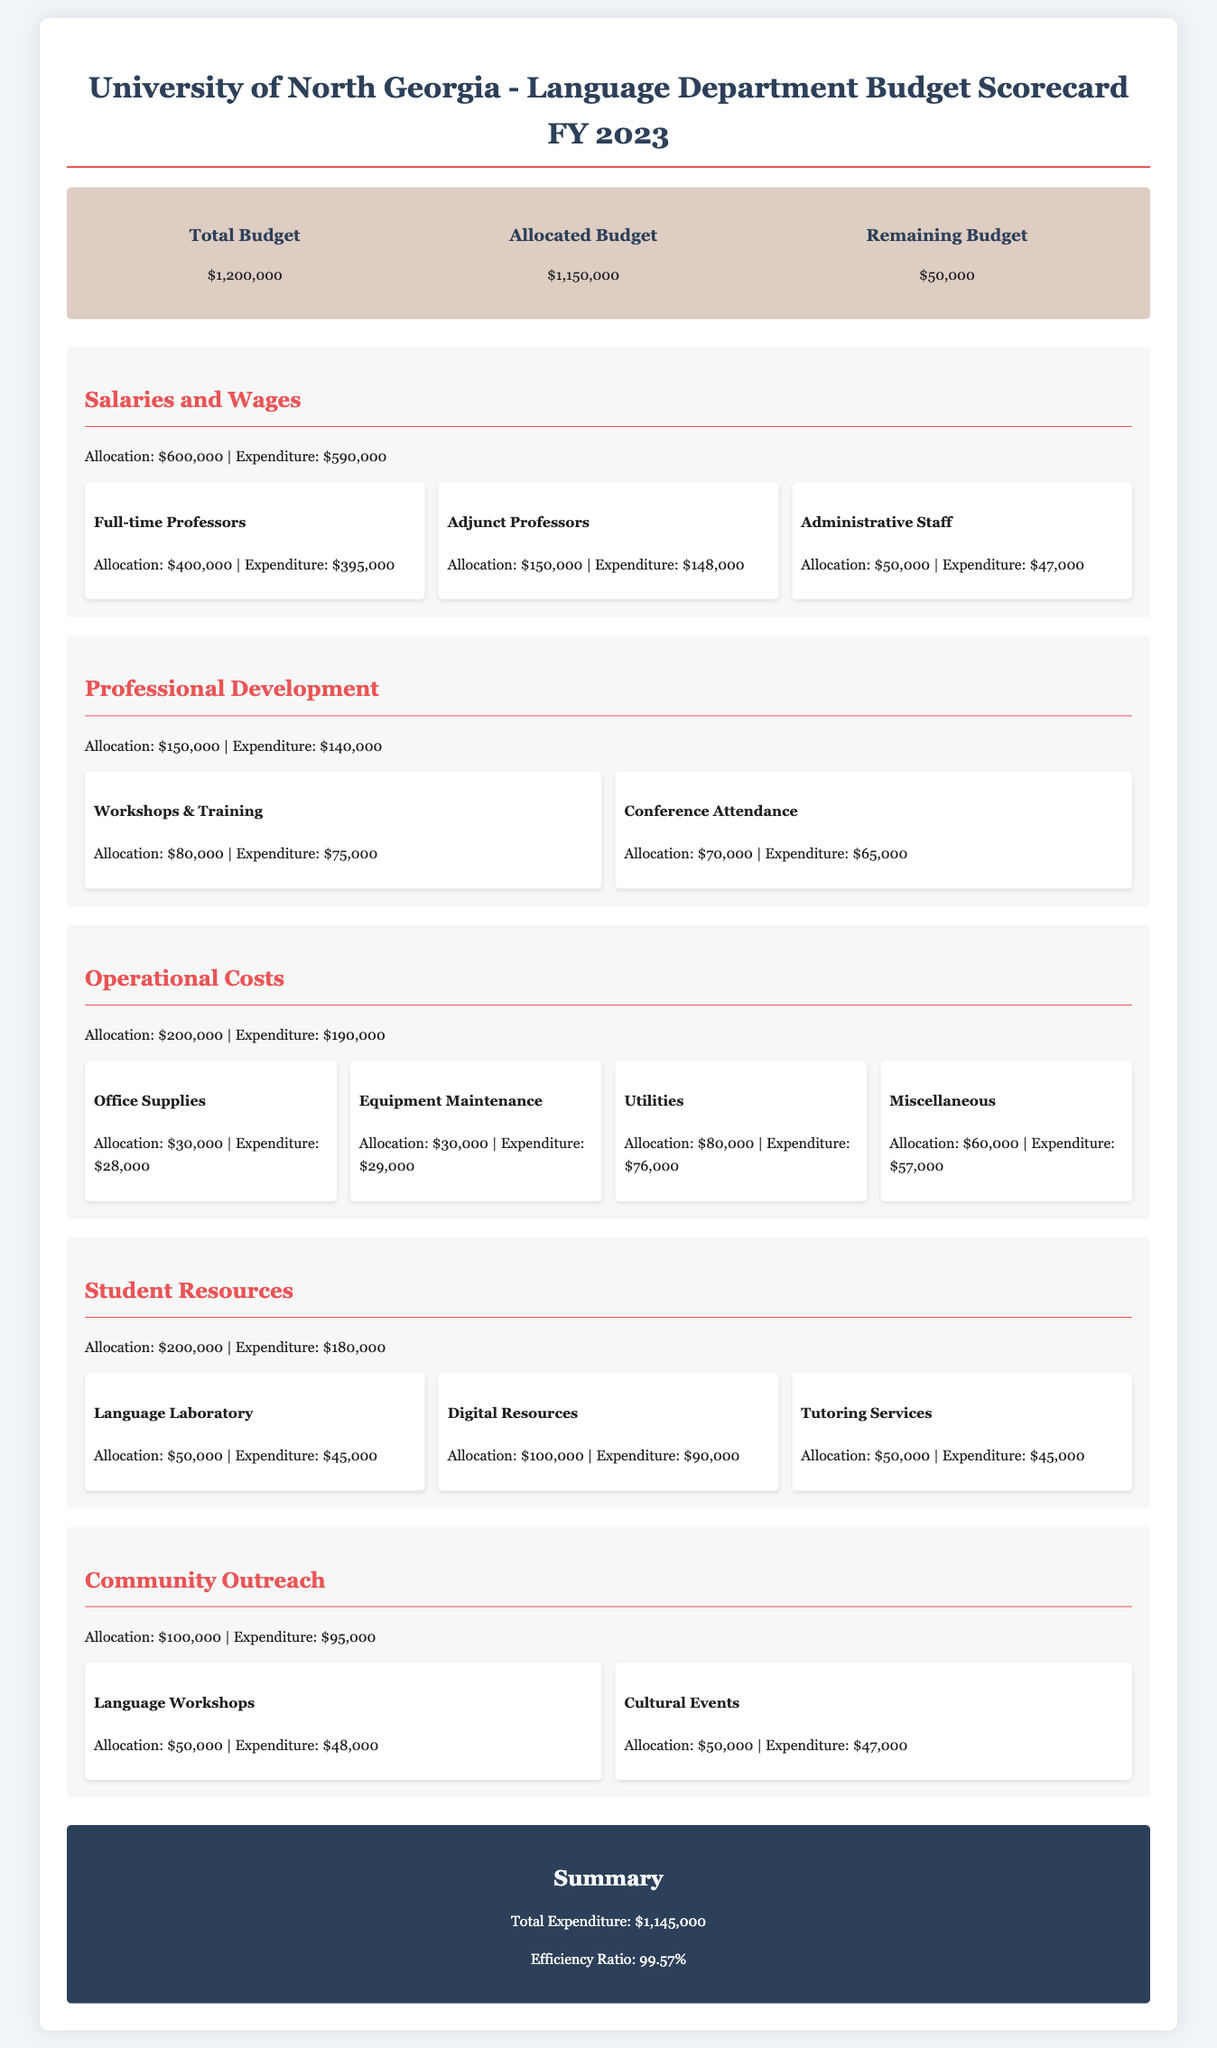What is the total budget for the Language Department? The total budget is stated in the overview section of the document.
Answer: $1,200,000 What is the allocated budget for salaries and wages? The allocation for salaries and wages is found under the Salaries and Wages category.
Answer: $600,000 What was the expenditure for community outreach? The expenditure for community outreach is detailed in the Community Outreach category.
Answer: $95,000 How much is the remaining budget after allocations? The remaining budget is calculated from the total budget minus the allocated budget.
Answer: $50,000 What is the efficiency ratio of the budget? The efficiency ratio is provided in the summary section of the document.
Answer: 99.57% What was allocated for professional development? The allocation for professional development is specified in its respective category.
Answer: $150,000 Which category has the highest allocation? By examining the allocations provided, you can determine the category with the highest total.
Answer: Salaries and Wages What is the total expenditure for operational costs? The total expenditure for operational costs can be summed from the detailed expenditures under that category.
Answer: $190,000 